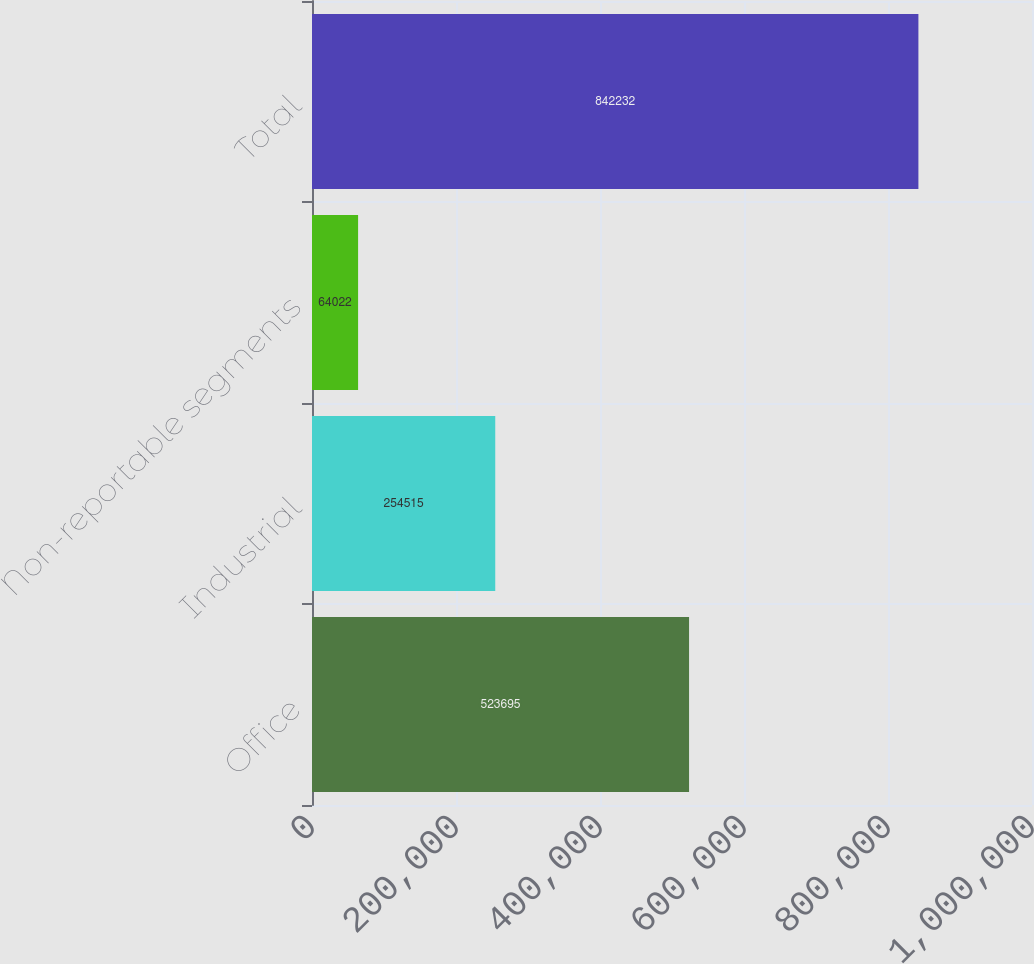Convert chart to OTSL. <chart><loc_0><loc_0><loc_500><loc_500><bar_chart><fcel>Office<fcel>Industrial<fcel>Non-reportable segments<fcel>Total<nl><fcel>523695<fcel>254515<fcel>64022<fcel>842232<nl></chart> 